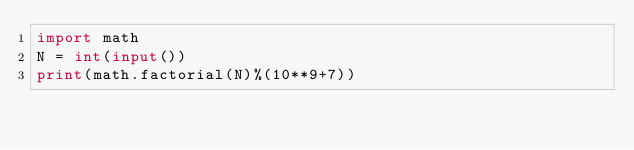Convert code to text. <code><loc_0><loc_0><loc_500><loc_500><_Python_>import math
N = int(input())
print(math.factorial(N)%(10**9+7))</code> 